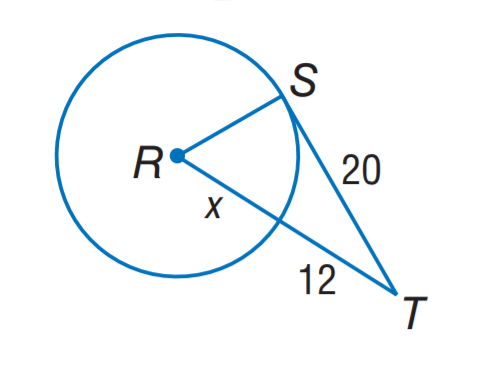Question: The segment is tangent to the circle. Find x. Round to the nearest tenth.
Choices:
A. 8.0
B. 10.7
C. 13.5
D. 22.7
Answer with the letter. Answer: B 